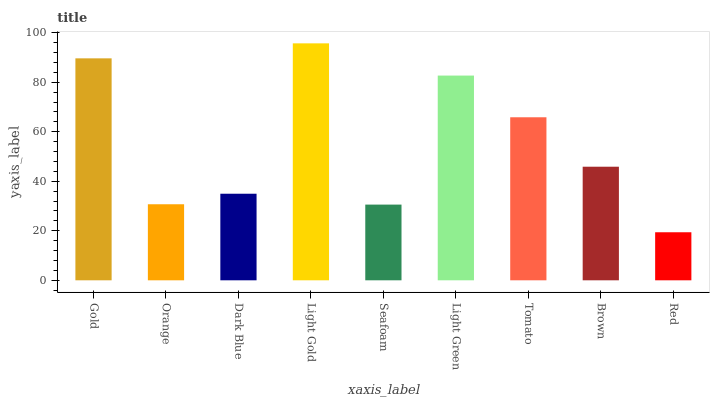Is Red the minimum?
Answer yes or no. Yes. Is Light Gold the maximum?
Answer yes or no. Yes. Is Orange the minimum?
Answer yes or no. No. Is Orange the maximum?
Answer yes or no. No. Is Gold greater than Orange?
Answer yes or no. Yes. Is Orange less than Gold?
Answer yes or no. Yes. Is Orange greater than Gold?
Answer yes or no. No. Is Gold less than Orange?
Answer yes or no. No. Is Brown the high median?
Answer yes or no. Yes. Is Brown the low median?
Answer yes or no. Yes. Is Gold the high median?
Answer yes or no. No. Is Red the low median?
Answer yes or no. No. 